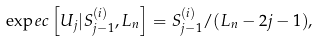Convert formula to latex. <formula><loc_0><loc_0><loc_500><loc_500>\exp e c \left [ U _ { j } | S _ { j - 1 } ^ { ( i ) } , L _ { n } \right ] = S _ { j - 1 } ^ { ( i ) } / ( L _ { n } - 2 j - 1 ) ,</formula> 